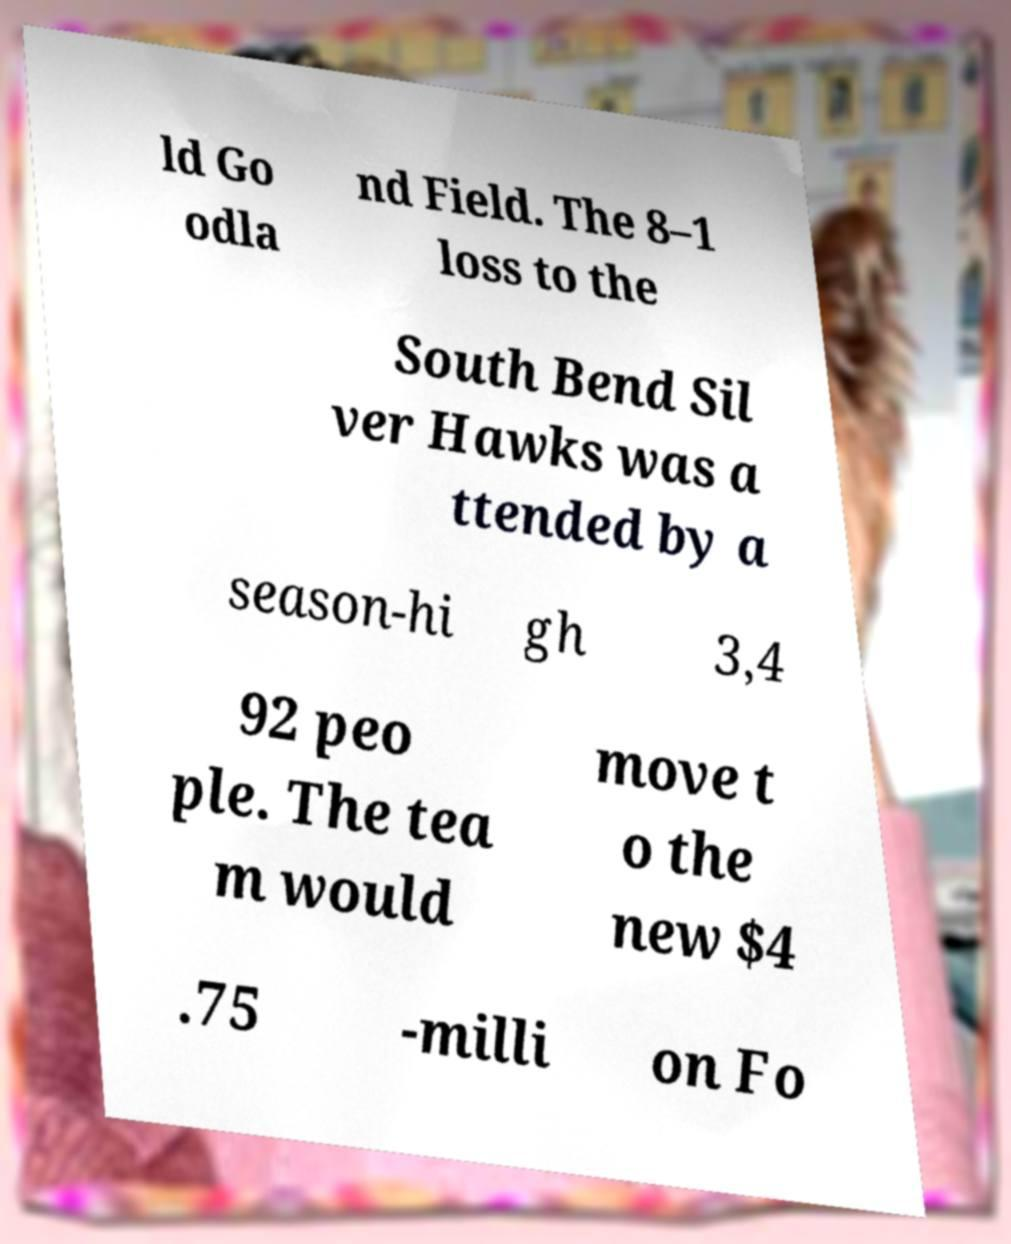Could you assist in decoding the text presented in this image and type it out clearly? ld Go odla nd Field. The 8–1 loss to the South Bend Sil ver Hawks was a ttended by a season-hi gh 3,4 92 peo ple. The tea m would move t o the new $4 .75 -milli on Fo 